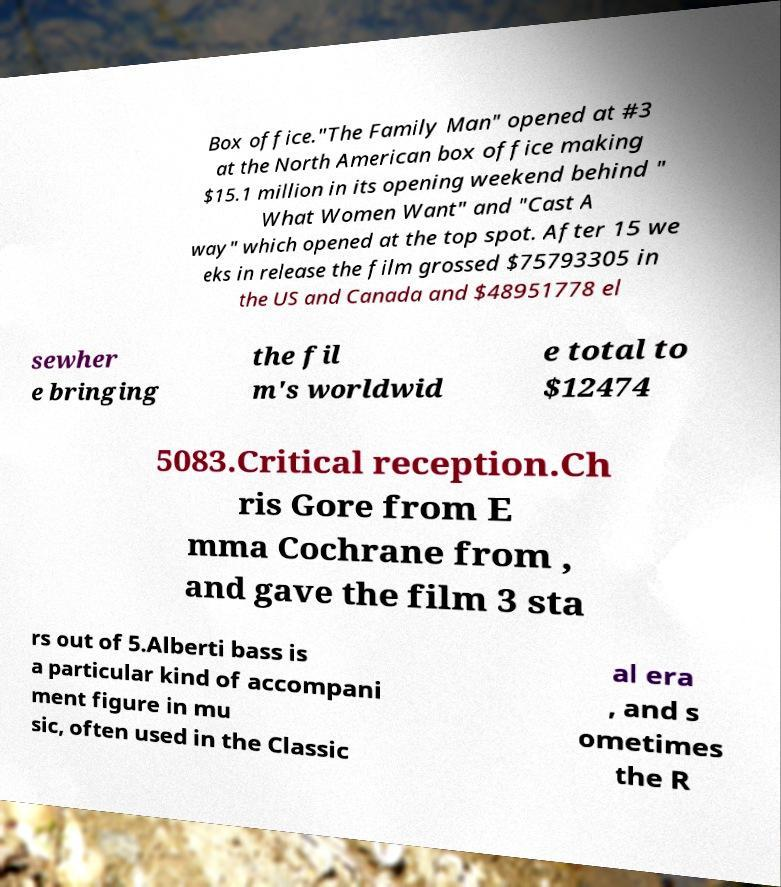Could you extract and type out the text from this image? Box office."The Family Man" opened at #3 at the North American box office making $15.1 million in its opening weekend behind " What Women Want" and "Cast A way" which opened at the top spot. After 15 we eks in release the film grossed $75793305 in the US and Canada and $48951778 el sewher e bringing the fil m's worldwid e total to $12474 5083.Critical reception.Ch ris Gore from E mma Cochrane from , and gave the film 3 sta rs out of 5.Alberti bass is a particular kind of accompani ment figure in mu sic, often used in the Classic al era , and s ometimes the R 